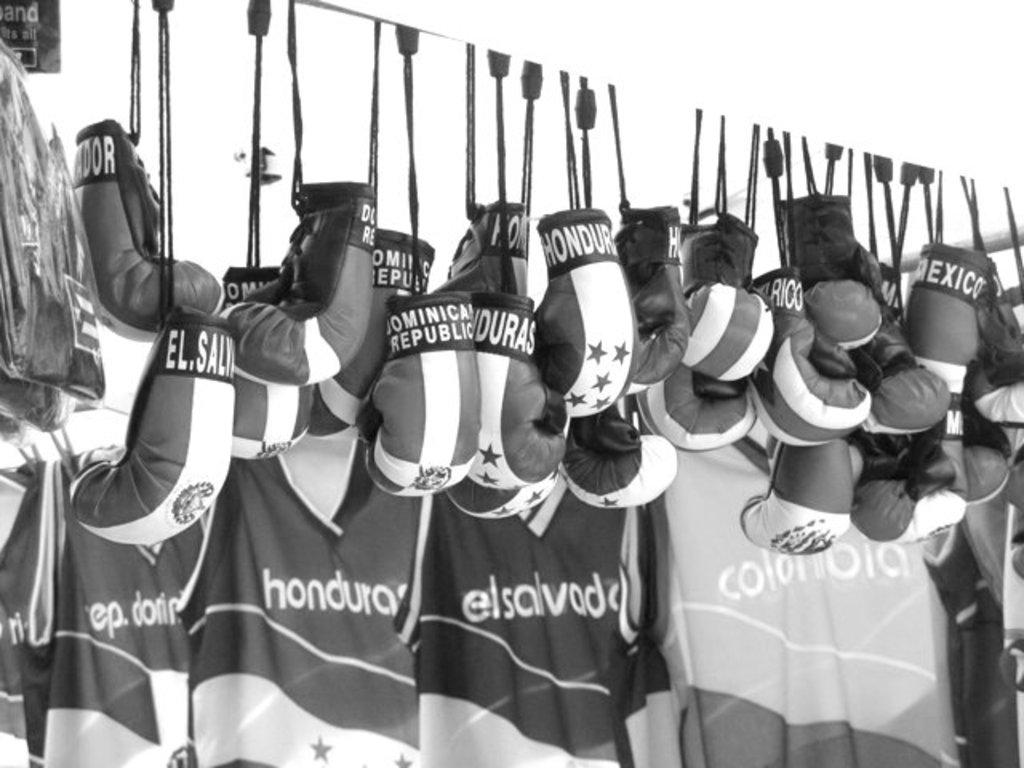What country is shown on the shirt on the right?
Offer a terse response. Colombia. 